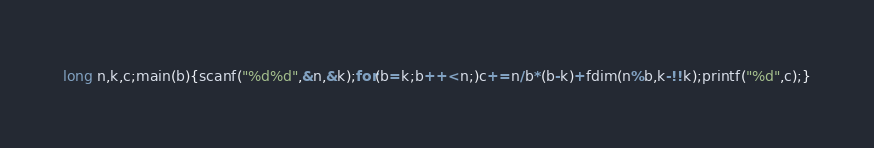<code> <loc_0><loc_0><loc_500><loc_500><_C_>long n,k,c;main(b){scanf("%d%d",&n,&k);for(b=k;b++<n;)c+=n/b*(b-k)+fdim(n%b,k-!!k);printf("%d",c);}</code> 